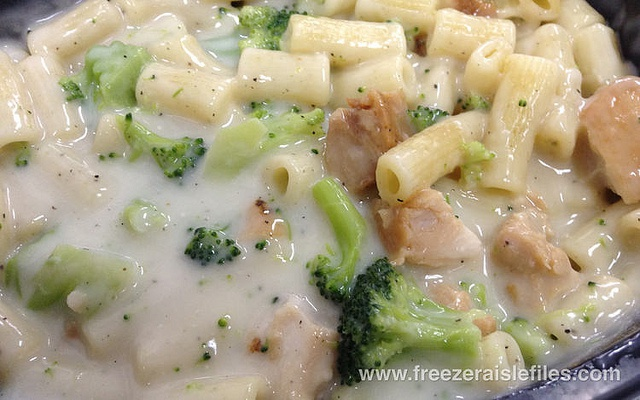Describe the objects in this image and their specific colors. I can see broccoli in black, olive, darkgreen, and darkgray tones, bowl in black, gray, and darkgray tones, broccoli in black, olive, darkgray, and beige tones, broccoli in black and olive tones, and broccoli in black, olive, darkgreen, gray, and darkgray tones in this image. 